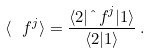Convert formula to latex. <formula><loc_0><loc_0><loc_500><loc_500>\langle \ f ^ { j } \rangle = \frac { \langle 2 | { \hat { \ } f } ^ { j } | 1 \rangle } { \langle 2 | 1 \rangle } \, .</formula> 